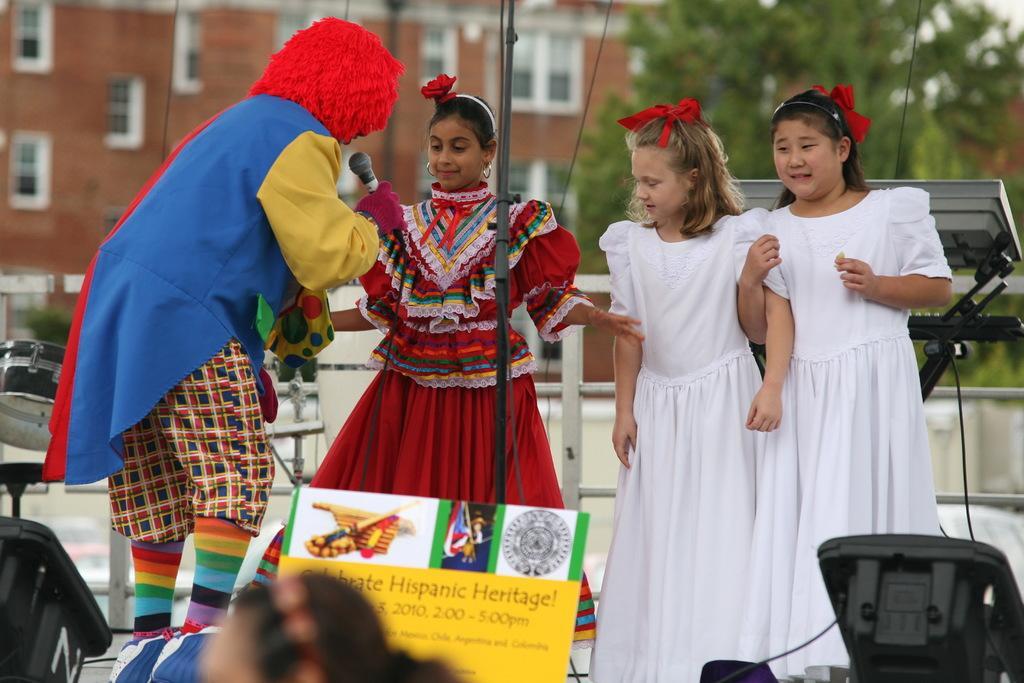How would you summarize this image in a sentence or two? In this picture we can see three girls and one person, he is holding a microphone. We can see board, devices, musical instrument, pole and fence. In the background it is blurry and we can see tree and building. 